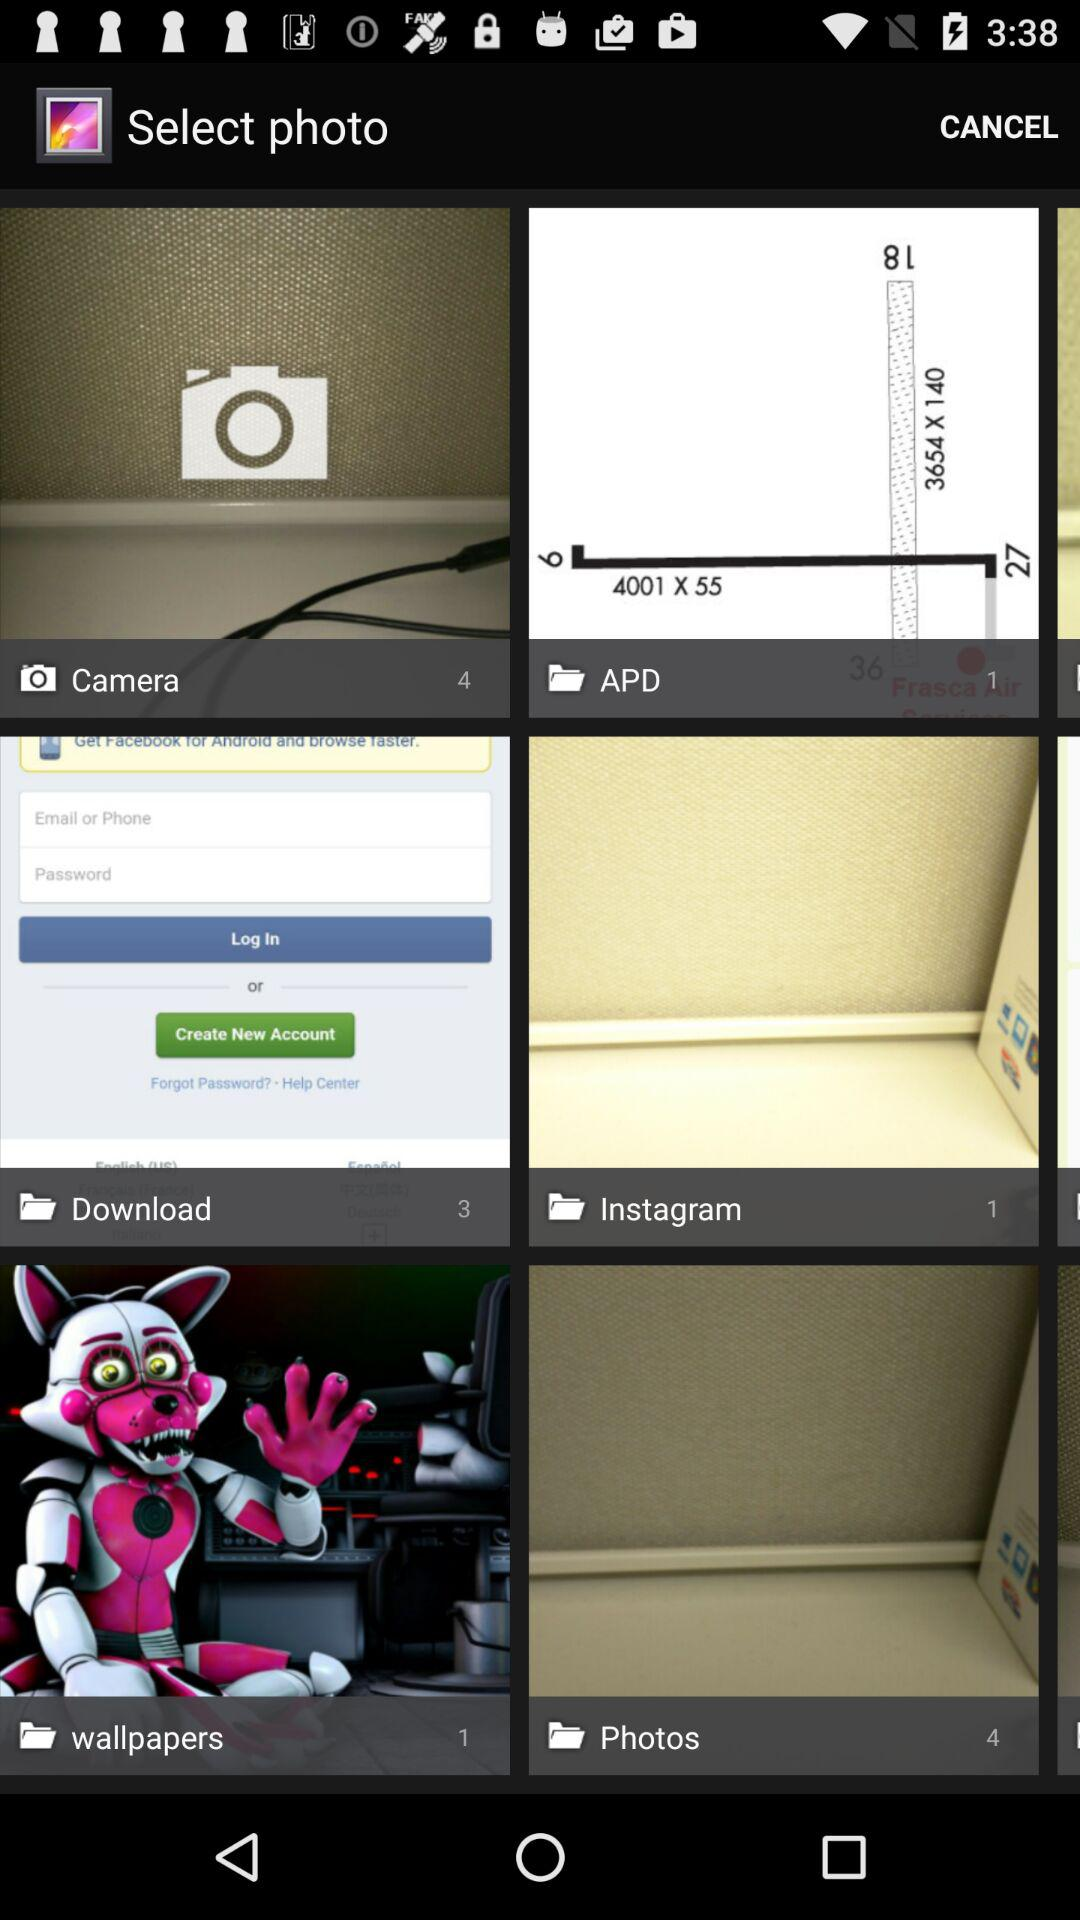What is the count of pictures in "APD"? The count is 1. 